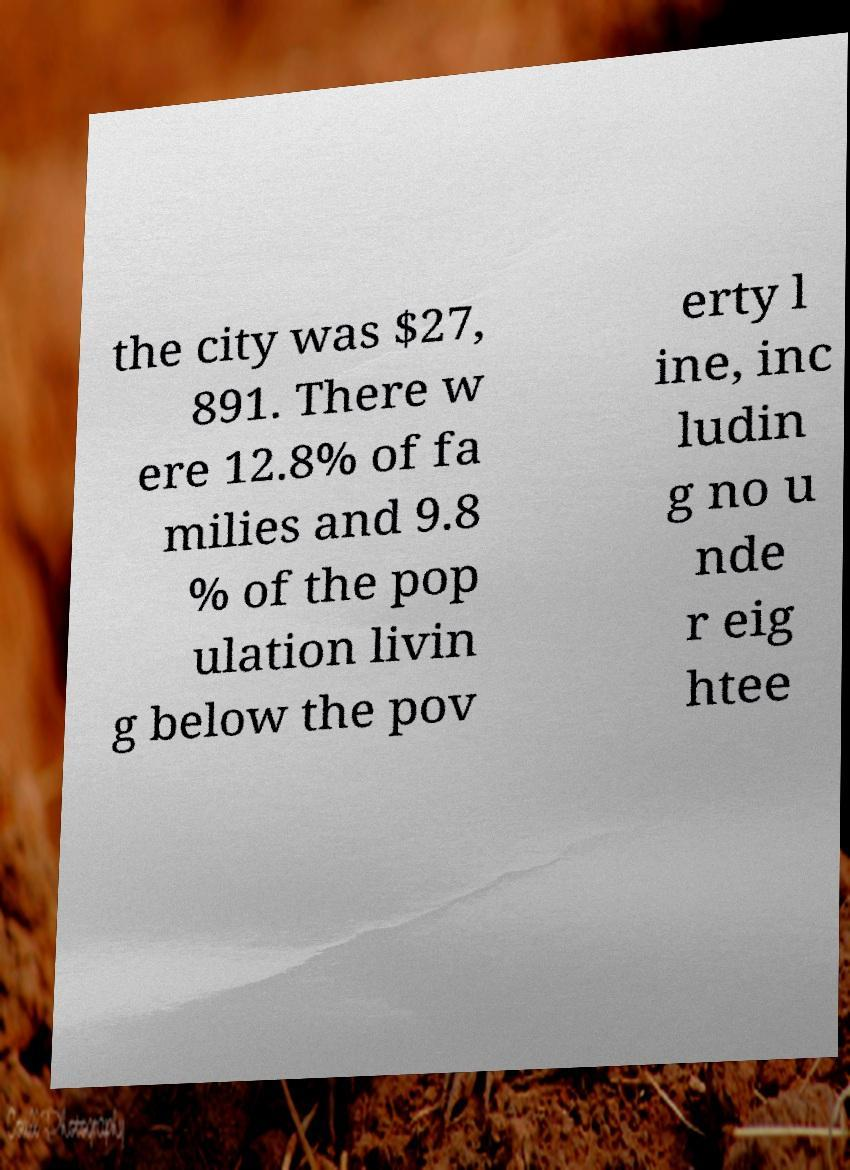What messages or text are displayed in this image? I need them in a readable, typed format. the city was $27, 891. There w ere 12.8% of fa milies and 9.8 % of the pop ulation livin g below the pov erty l ine, inc ludin g no u nde r eig htee 